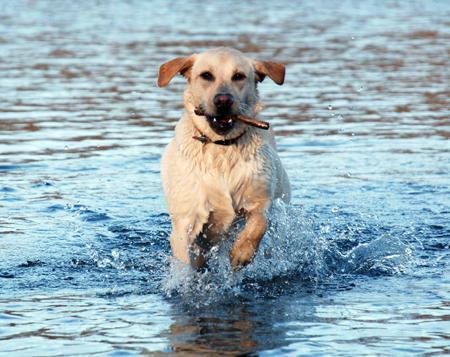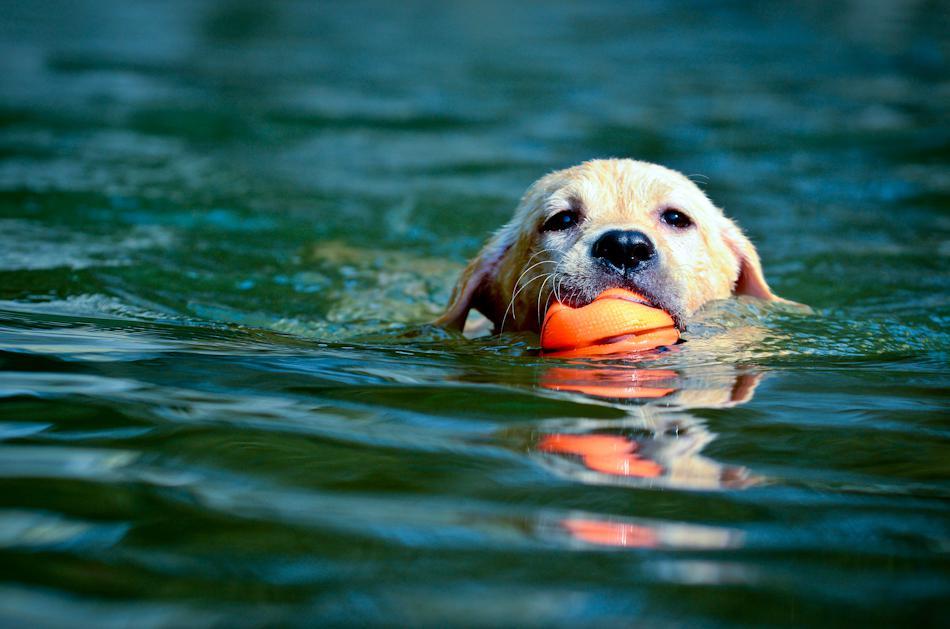The first image is the image on the left, the second image is the image on the right. Evaluate the accuracy of this statement regarding the images: "Two dogs are swimming through water up to their chin.". Is it true? Answer yes or no. No. 